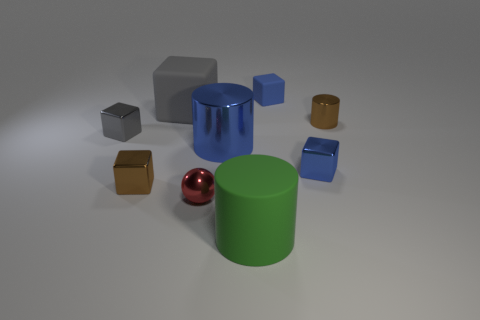There is a metallic cylinder right of the metallic cylinder left of the large green rubber object; what is its size?
Make the answer very short. Small. Is the small brown thing that is on the left side of the green object made of the same material as the small brown thing to the right of the rubber cylinder?
Keep it short and to the point. Yes. Does the shiny block that is on the right side of the large shiny cylinder have the same color as the big shiny thing?
Provide a short and direct response. Yes. There is a green rubber cylinder; how many small blue things are on the left side of it?
Provide a succinct answer. 0. Do the tiny red thing and the blue thing behind the small brown cylinder have the same material?
Give a very brief answer. No. There is a gray cube that is the same material as the tiny red thing; what is its size?
Your answer should be compact. Small. Is the number of small gray shiny cubes that are right of the small gray metallic cube greater than the number of cylinders that are behind the large green cylinder?
Your answer should be compact. No. Are there any large cyan metal objects that have the same shape as the red metal object?
Keep it short and to the point. No. There is a rubber cube behind the gray rubber cube; does it have the same size as the small brown shiny block?
Your response must be concise. Yes. Is there a small matte cube?
Your answer should be very brief. Yes. 